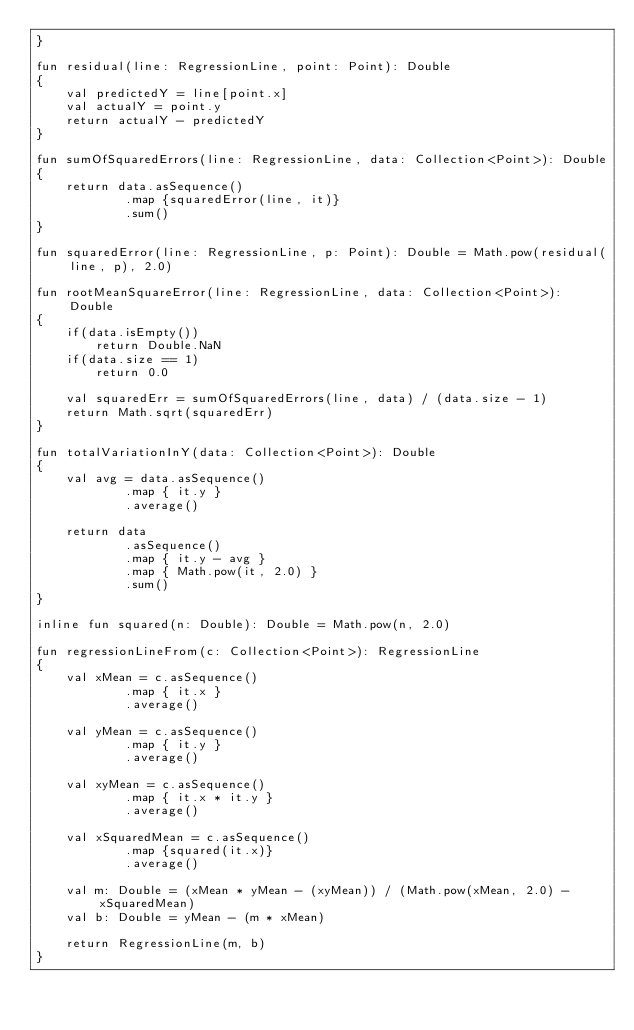<code> <loc_0><loc_0><loc_500><loc_500><_Kotlin_>}

fun residual(line: RegressionLine, point: Point): Double
{
	val predictedY = line[point.x]
	val actualY = point.y
	return actualY - predictedY
}

fun sumOfSquaredErrors(line: RegressionLine, data: Collection<Point>): Double
{
	return data.asSequence()
			.map {squaredError(line, it)}
			.sum()
}

fun squaredError(line: RegressionLine, p: Point): Double = Math.pow(residual(line, p), 2.0)

fun rootMeanSquareError(line: RegressionLine, data: Collection<Point>): Double
{
	if(data.isEmpty())
		return Double.NaN
	if(data.size == 1)
		return 0.0

	val squaredErr = sumOfSquaredErrors(line, data) / (data.size - 1)
	return Math.sqrt(squaredErr)
}

fun totalVariationInY(data: Collection<Point>): Double
{
	val avg = data.asSequence()
			.map { it.y }
			.average()

	return data
			.asSequence()
			.map { it.y - avg }
			.map { Math.pow(it, 2.0) }
			.sum()
}

inline fun squared(n: Double): Double = Math.pow(n, 2.0)

fun regressionLineFrom(c: Collection<Point>): RegressionLine
{
	val xMean = c.asSequence()
			.map { it.x }
			.average()

	val yMean = c.asSequence()
			.map { it.y }
			.average()

	val xyMean = c.asSequence()
			.map { it.x * it.y }
			.average()

	val xSquaredMean = c.asSequence()
			.map {squared(it.x)}
			.average()

	val m: Double = (xMean * yMean - (xyMean)) / (Math.pow(xMean, 2.0) - xSquaredMean)
	val b: Double = yMean - (m * xMean)

	return RegressionLine(m, b)
}</code> 